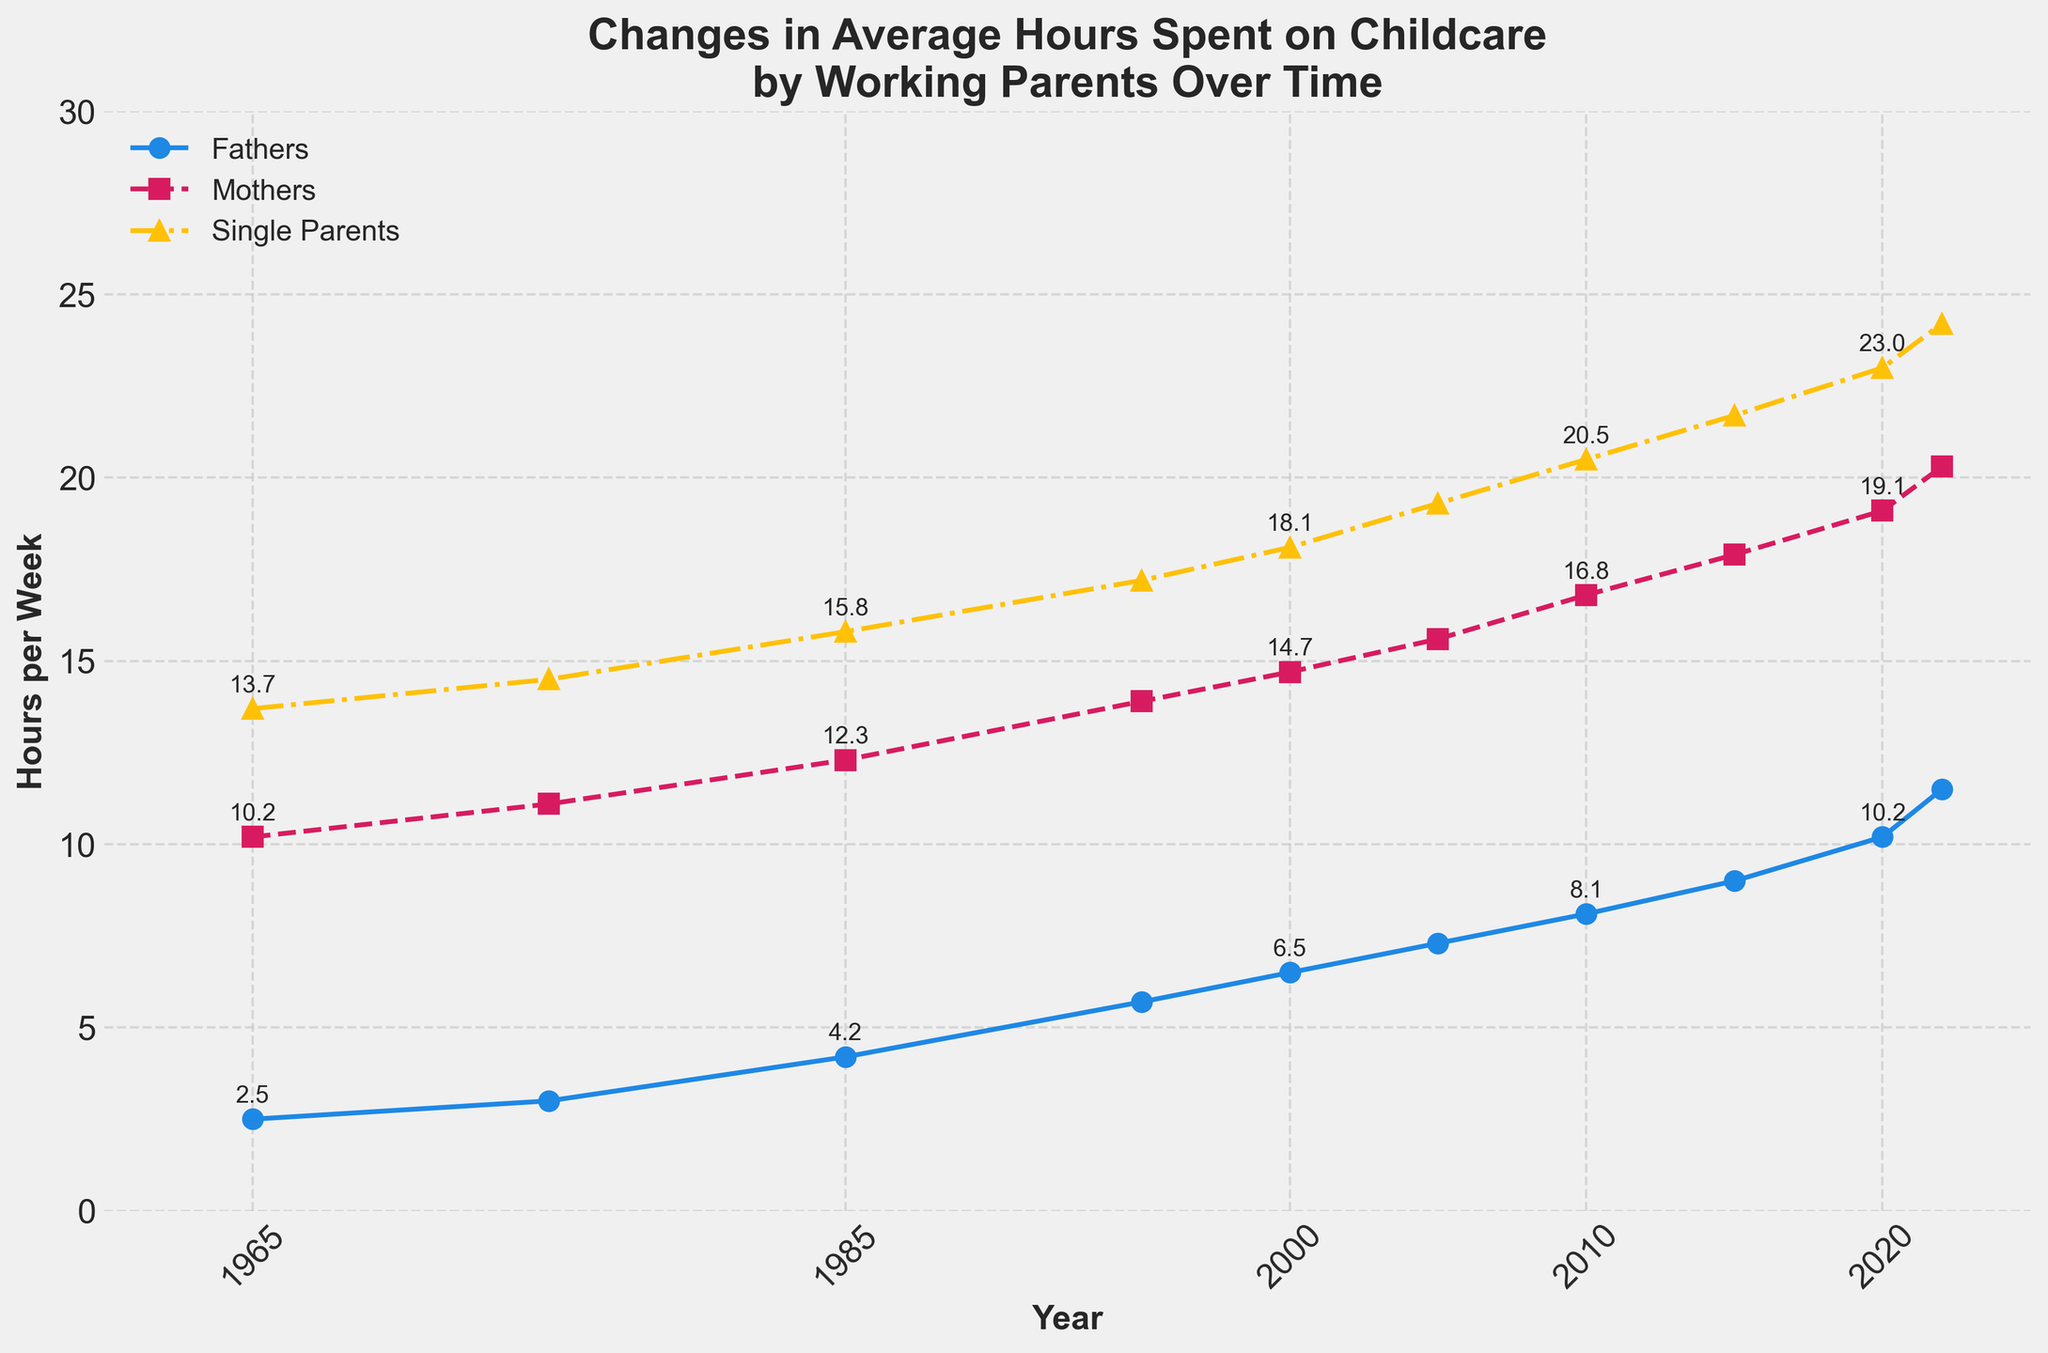What is the average number of hours spent on childcare by fathers in 1975 and 1985? The hours in 1975 and 1985 are 3.0 and 4.2 respectively. Average = (3.0 + 4.2) / 2 = 3.6 hours/week.
Answer: 3.6 hours/week Between 1965 and 2022, in which year did mothers spend the most hours on childcare per week? From the chart, mothers spent the most time in 2022.
Answer: 2022 By how much did the weekly childcare hours of single parents increase from 1965 to 2022? The hours spent in 1965 were 13.7, and in 2022 it was 24.2. The increase is 24.2 - 13.7 = 10.5 hours/week.
Answer: 10.5 hours/week Which group consistently spent more time on childcare throughout the years: fathers, mothers, or single parents? From the figure, single parents have consistently spent the most time each year.
Answer: Single parents By how many hours did childcare time by fathers surpass the 5-hour mark, and in which year did this occur? Fathers surpassed 5 hours in 1995 with 5.7 hours/week. The surplus is 5.7 - 5 = 0.7 hours/week.
Answer: 0.7 hours/week in 1995 Compare the childcare hours of mothers in 2000 and fathers in 2020. Which group spent more time and by how much? Mothers in 2000 spent 14.7 hours/week, fathers in 2020 spent 10.2 hours/week. Difference = 14.7 - 10.2 = 4.5 hours/week.
Answer: Mothers by 4.5 hours/week What is the total increase in hours spent on childcare by mothers from 1965 to 2015? Mothers spent 10.2 hours/week in 1965 and 17.9 in 2015. The increase is 17.9 - 10.2 = 7.7 hours/week.
Answer: 7.7 hours/week What is the sum of the hours spent on childcare by single parents in the years 1985, 1995, and 2005? Adding up hours: 1985 (15.8), 1995 (17.2), and 2005 (19.3) gives 15.8 + 17.2 + 19.3 = 52.3 hours/week.
Answer: 52.3 hours/week In what year did the gap between hours spent by mothers and fathers on childcare reduce to less than 5 hours per week? In 2015, mothers spent 17.9 hours/week and fathers 9.0 hours/week, gap = 17.9 - 9.0 = 8.9 hours/week. In 2020, mothers spent 19.1 hours/week and fathers 10.2 hours/week, gap = 19.1 - 10.2 = 8.9 hours/week. So in year 2022, the hours difference is 20.3 - 11.5 = 8.8 hours/week.
Answer: Reduced before 2020 